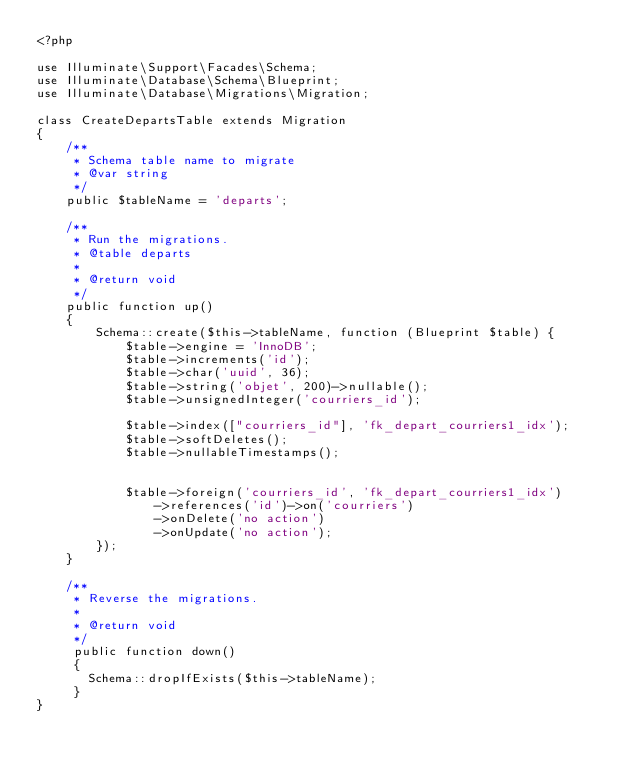Convert code to text. <code><loc_0><loc_0><loc_500><loc_500><_PHP_><?php

use Illuminate\Support\Facades\Schema;
use Illuminate\Database\Schema\Blueprint;
use Illuminate\Database\Migrations\Migration;

class CreateDepartsTable extends Migration
{
    /**
     * Schema table name to migrate
     * @var string
     */
    public $tableName = 'departs';

    /**
     * Run the migrations.
     * @table departs
     *
     * @return void
     */
    public function up()
    {
        Schema::create($this->tableName, function (Blueprint $table) {
            $table->engine = 'InnoDB';
            $table->increments('id');
            $table->char('uuid', 36);
            $table->string('objet', 200)->nullable();
            $table->unsignedInteger('courriers_id');

            $table->index(["courriers_id"], 'fk_depart_courriers1_idx');
            $table->softDeletes();
            $table->nullableTimestamps();


            $table->foreign('courriers_id', 'fk_depart_courriers1_idx')
                ->references('id')->on('courriers')
                ->onDelete('no action')
                ->onUpdate('no action');
        });
    }

    /**
     * Reverse the migrations.
     *
     * @return void
     */
     public function down()
     {
       Schema::dropIfExists($this->tableName);
     }
}
</code> 